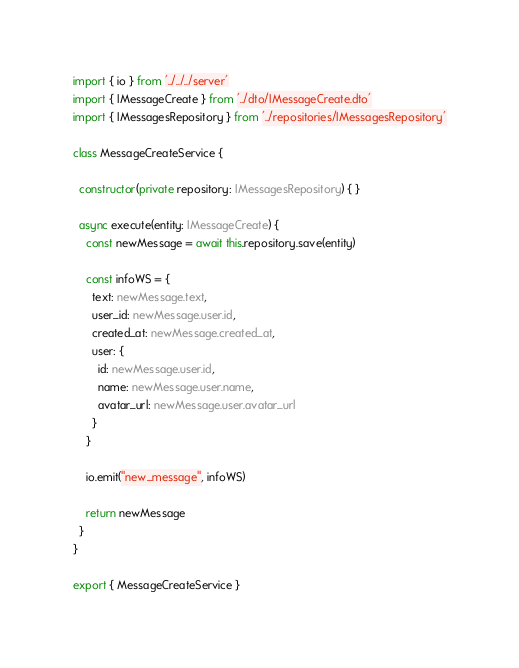<code> <loc_0><loc_0><loc_500><loc_500><_TypeScript_>import { io } from '../../../server'
import { IMessageCreate } from '../dto/IMessageCreate.dto'
import { IMessagesRepository } from '../repositories/IMessagesRepository'

class MessageCreateService {

  constructor(private repository: IMessagesRepository) { }

  async execute(entity: IMessageCreate) {
    const newMessage = await this.repository.save(entity)

    const infoWS = {
      text: newMessage.text,
      user_id: newMessage.user.id,
      created_at: newMessage.created_at,
      user: {
        id: newMessage.user.id,
        name: newMessage.user.name,
        avatar_url: newMessage.user.avatar_url
      }
    }

    io.emit("new_message", infoWS)

    return newMessage
  }
}

export { MessageCreateService }</code> 